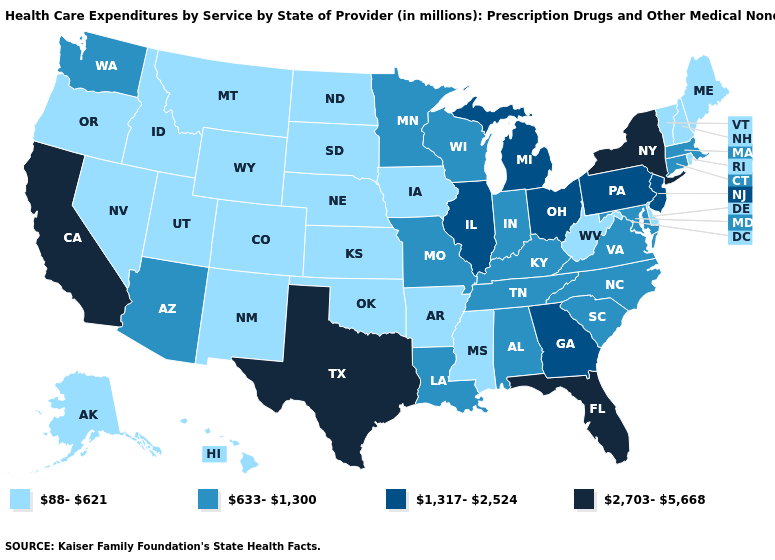Does Wyoming have the lowest value in the USA?
Keep it brief. Yes. What is the value of Michigan?
Concise answer only. 1,317-2,524. Name the states that have a value in the range 1,317-2,524?
Write a very short answer. Georgia, Illinois, Michigan, New Jersey, Ohio, Pennsylvania. Does Florida have the highest value in the USA?
Answer briefly. Yes. Which states have the highest value in the USA?
Write a very short answer. California, Florida, New York, Texas. Which states have the highest value in the USA?
Be succinct. California, Florida, New York, Texas. How many symbols are there in the legend?
Answer briefly. 4. Does the map have missing data?
Give a very brief answer. No. Does Nevada have a lower value than Minnesota?
Give a very brief answer. Yes. What is the value of Kansas?
Be succinct. 88-621. Which states hav the highest value in the West?
Quick response, please. California. Name the states that have a value in the range 2,703-5,668?
Give a very brief answer. California, Florida, New York, Texas. Among the states that border Utah , does Arizona have the lowest value?
Concise answer only. No. Name the states that have a value in the range 633-1,300?
Quick response, please. Alabama, Arizona, Connecticut, Indiana, Kentucky, Louisiana, Maryland, Massachusetts, Minnesota, Missouri, North Carolina, South Carolina, Tennessee, Virginia, Washington, Wisconsin. Does Tennessee have the same value as Virginia?
Be succinct. Yes. 